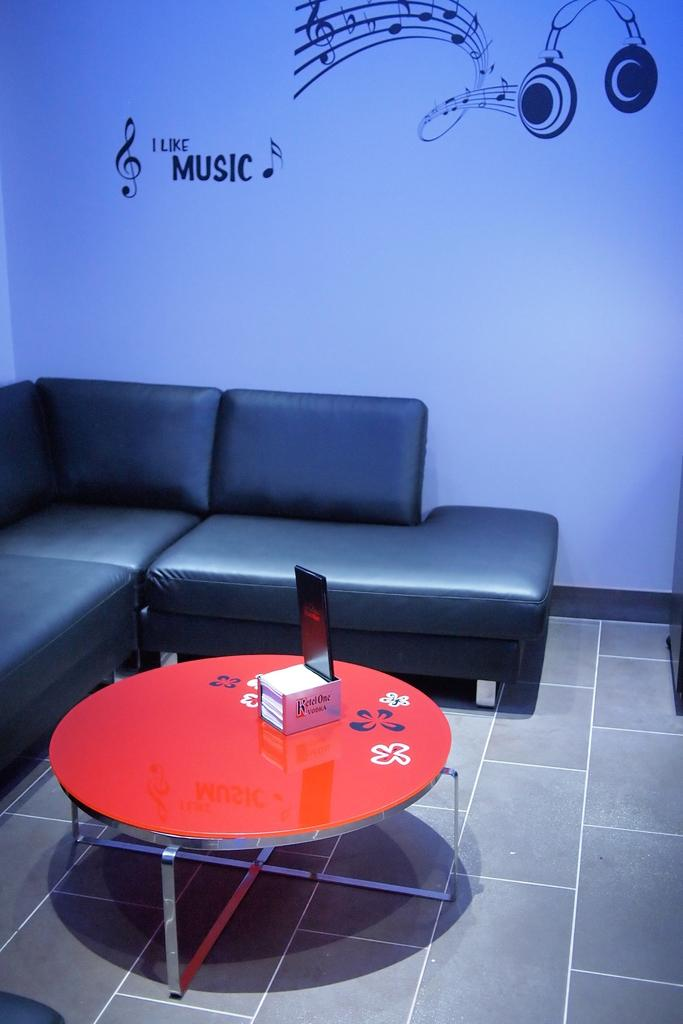What type of space is depicted in the image? There is a room in the image. What furniture is present in the room? There is a sofa and a table in the room. What electronic device is on the table? There is an iPad on the table. What type of artwork is featured in the room? There are paintings of musical headsets in the room. Where can you find a station to buy popcorn in the image? There is no station to buy popcorn present in the image. What type of feather is used as a decoration in the room? There is no feather present in the image. 